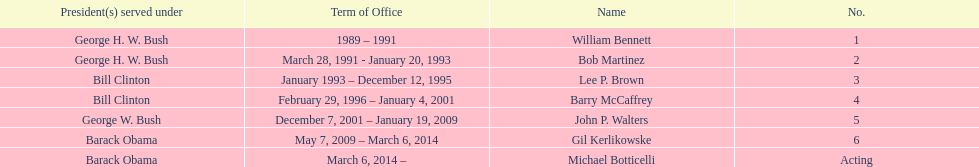What were the number of directors that stayed in office more than three years? 3. 